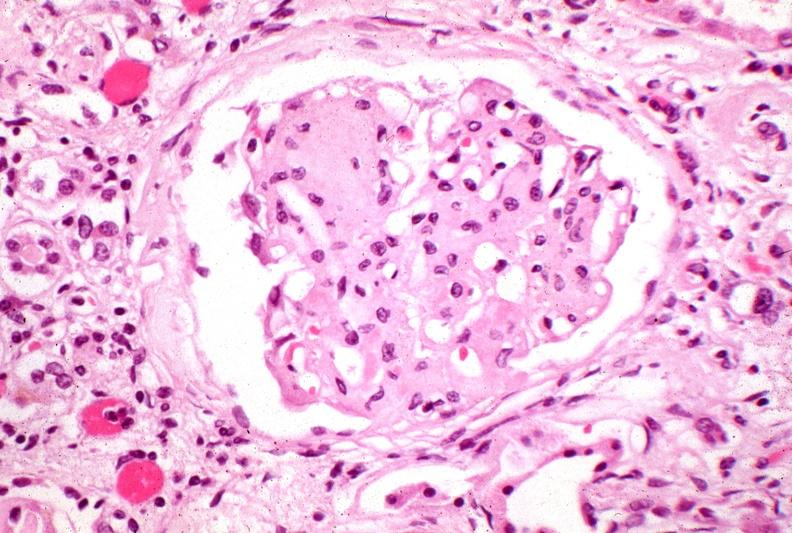does this image show kidney, kw kimmelstiel-wilson?
Answer the question using a single word or phrase. Yes 